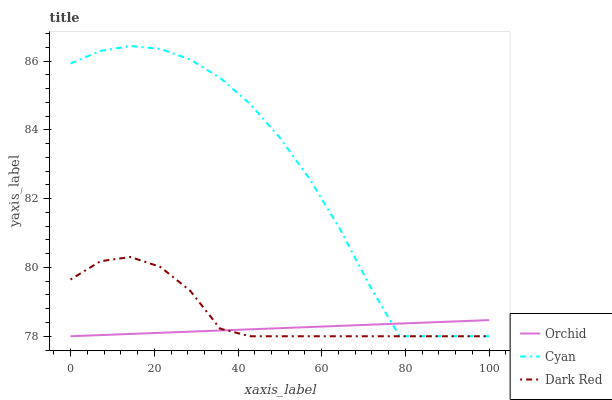Does Orchid have the minimum area under the curve?
Answer yes or no. Yes. Does Cyan have the maximum area under the curve?
Answer yes or no. Yes. Does Dark Red have the minimum area under the curve?
Answer yes or no. No. Does Dark Red have the maximum area under the curve?
Answer yes or no. No. Is Orchid the smoothest?
Answer yes or no. Yes. Is Cyan the roughest?
Answer yes or no. Yes. Is Dark Red the smoothest?
Answer yes or no. No. Is Dark Red the roughest?
Answer yes or no. No. Does Cyan have the lowest value?
Answer yes or no. Yes. Does Cyan have the highest value?
Answer yes or no. Yes. Does Dark Red have the highest value?
Answer yes or no. No. Does Dark Red intersect Cyan?
Answer yes or no. Yes. Is Dark Red less than Cyan?
Answer yes or no. No. Is Dark Red greater than Cyan?
Answer yes or no. No. 